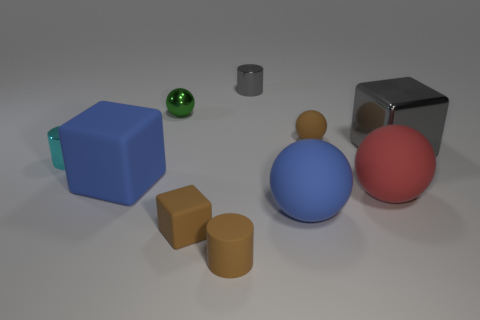Is there a large blue sphere made of the same material as the red ball?
Give a very brief answer. Yes. What color is the shiny object that is in front of the small green metal ball and on the left side of the red object?
Give a very brief answer. Cyan. How many other objects are the same color as the tiny matte sphere?
Give a very brief answer. 2. The tiny brown thing behind the gray thing that is to the right of the tiny metal cylinder behind the cyan metallic thing is made of what material?
Provide a succinct answer. Rubber. What number of cylinders are either tiny gray objects or cyan things?
Your answer should be very brief. 2. Is there anything else that has the same size as the red object?
Provide a short and direct response. Yes. What number of red balls are left of the cylinder on the left side of the small cylinder that is in front of the large red rubber sphere?
Give a very brief answer. 0. Is the green metal thing the same shape as the large shiny object?
Offer a very short reply. No. Is the material of the brown object left of the brown cylinder the same as the tiny brown object that is behind the gray block?
Provide a short and direct response. Yes. How many objects are either blue rubber objects that are left of the small green metallic ball or small objects that are to the right of the cyan metallic object?
Provide a short and direct response. 6. 